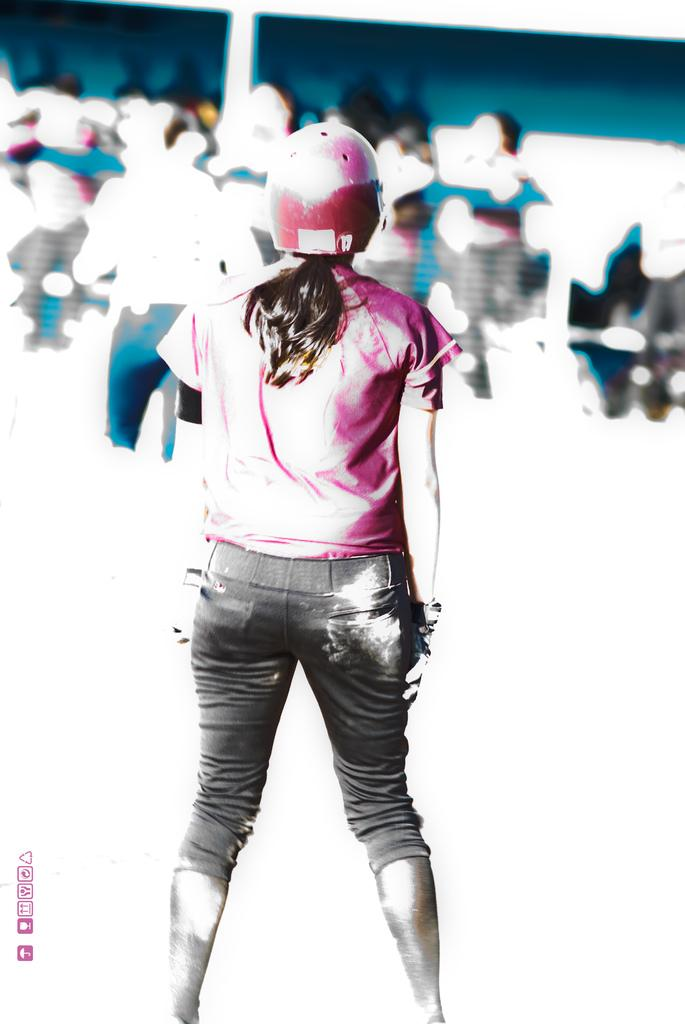Who is the main subject in the image? There is a girl in the image. What is the girl wearing on her upper body? The girl is wearing a pink t-shirt. What type of pants is the girl wearing? The girl is wearing jeans. What type of headgear is the girl wearing? The girl is wearing a pink helmet. Can you describe the background of the image? The background of the image is blurry. What is the girl's tendency to experience pleasure in the image? There is no information about the girl's emotions or experiences in the image, so it is not possible to determine her tendency to experience pleasure. 